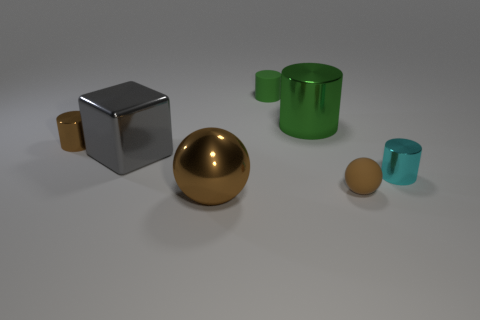Subtract all big green cylinders. How many cylinders are left? 3 Add 1 tiny spheres. How many objects exist? 8 Subtract all cyan cylinders. How many cylinders are left? 3 Subtract 2 balls. How many balls are left? 0 Subtract all cyan blocks. Subtract all brown balls. How many blocks are left? 1 Subtract all yellow spheres. How many brown blocks are left? 0 Subtract all matte cylinders. Subtract all big cylinders. How many objects are left? 5 Add 4 green cylinders. How many green cylinders are left? 6 Add 5 large yellow metal spheres. How many large yellow metal spheres exist? 5 Subtract 0 brown blocks. How many objects are left? 7 